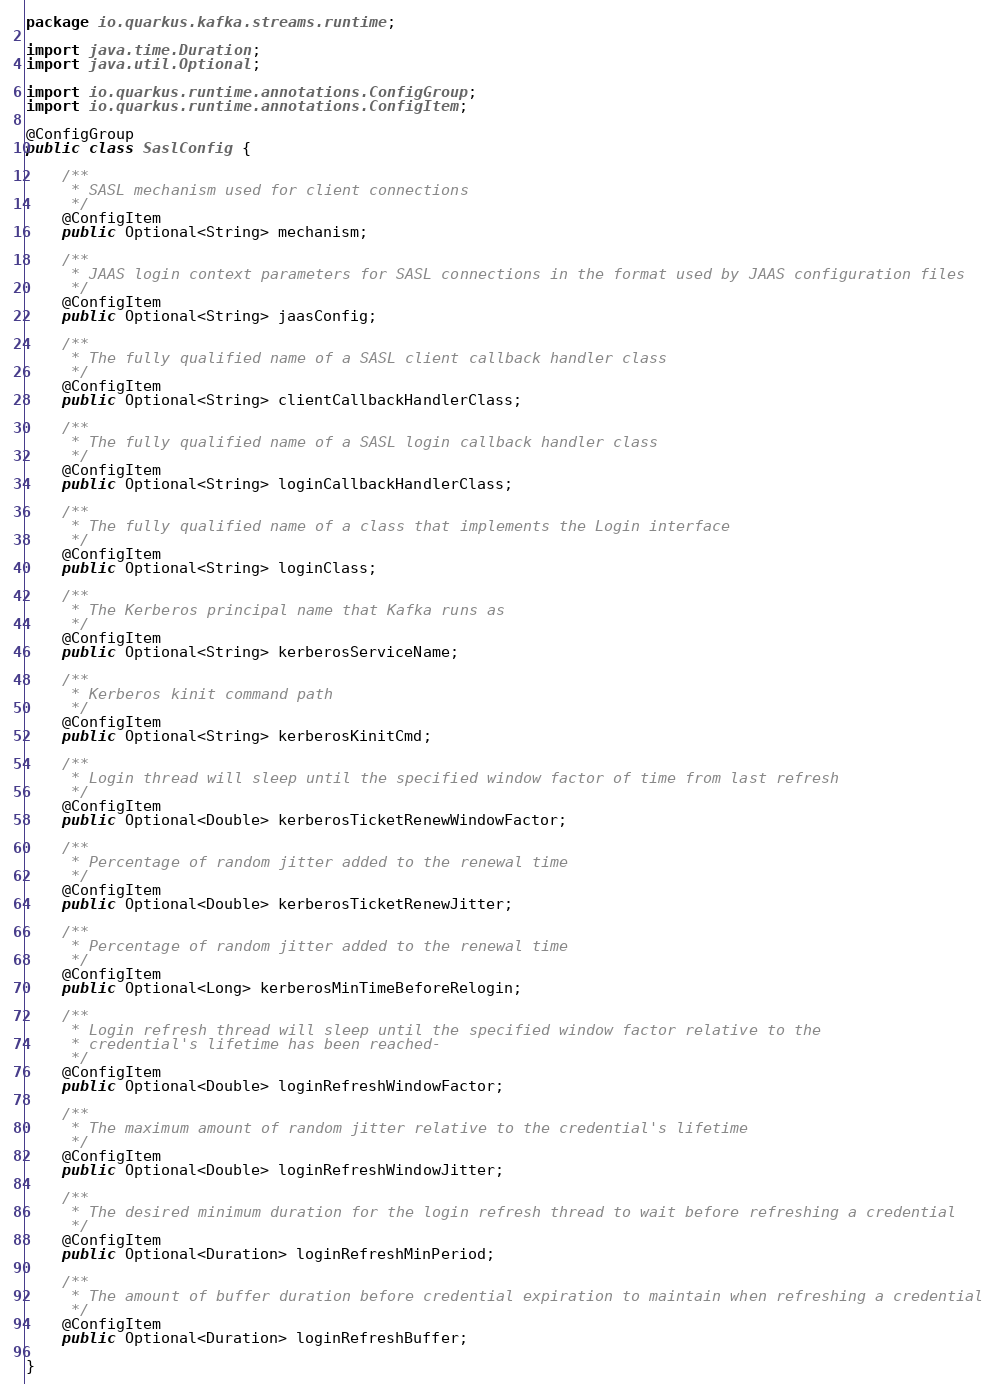Convert code to text. <code><loc_0><loc_0><loc_500><loc_500><_Java_>package io.quarkus.kafka.streams.runtime;

import java.time.Duration;
import java.util.Optional;

import io.quarkus.runtime.annotations.ConfigGroup;
import io.quarkus.runtime.annotations.ConfigItem;

@ConfigGroup
public class SaslConfig {

    /**
     * SASL mechanism used for client connections
     */
    @ConfigItem
    public Optional<String> mechanism;

    /**
     * JAAS login context parameters for SASL connections in the format used by JAAS configuration files
     */
    @ConfigItem
    public Optional<String> jaasConfig;

    /**
     * The fully qualified name of a SASL client callback handler class
     */
    @ConfigItem
    public Optional<String> clientCallbackHandlerClass;

    /**
     * The fully qualified name of a SASL login callback handler class
     */
    @ConfigItem
    public Optional<String> loginCallbackHandlerClass;

    /**
     * The fully qualified name of a class that implements the Login interface
     */
    @ConfigItem
    public Optional<String> loginClass;

    /**
     * The Kerberos principal name that Kafka runs as
     */
    @ConfigItem
    public Optional<String> kerberosServiceName;

    /**
     * Kerberos kinit command path
     */
    @ConfigItem
    public Optional<String> kerberosKinitCmd;

    /**
     * Login thread will sleep until the specified window factor of time from last refresh
     */
    @ConfigItem
    public Optional<Double> kerberosTicketRenewWindowFactor;

    /**
     * Percentage of random jitter added to the renewal time
     */
    @ConfigItem
    public Optional<Double> kerberosTicketRenewJitter;

    /**
     * Percentage of random jitter added to the renewal time
     */
    @ConfigItem
    public Optional<Long> kerberosMinTimeBeforeRelogin;

    /**
     * Login refresh thread will sleep until the specified window factor relative to the
     * credential's lifetime has been reached-
     */
    @ConfigItem
    public Optional<Double> loginRefreshWindowFactor;

    /**
     * The maximum amount of random jitter relative to the credential's lifetime
     */
    @ConfigItem
    public Optional<Double> loginRefreshWindowJitter;

    /**
     * The desired minimum duration for the login refresh thread to wait before refreshing a credential
     */
    @ConfigItem
    public Optional<Duration> loginRefreshMinPeriod;

    /**
     * The amount of buffer duration before credential expiration to maintain when refreshing a credential
     */
    @ConfigItem
    public Optional<Duration> loginRefreshBuffer;

}
</code> 